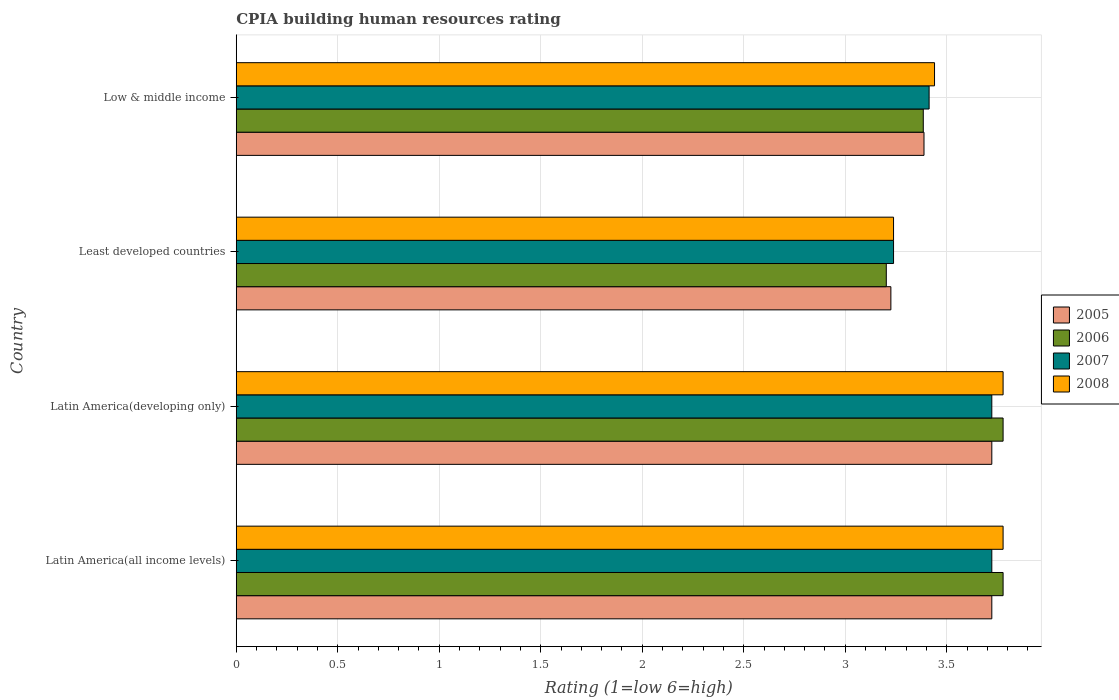Are the number of bars per tick equal to the number of legend labels?
Make the answer very short. Yes. What is the label of the 3rd group of bars from the top?
Keep it short and to the point. Latin America(developing only). In how many cases, is the number of bars for a given country not equal to the number of legend labels?
Ensure brevity in your answer.  0. What is the CPIA rating in 2005 in Latin America(developing only)?
Provide a succinct answer. 3.72. Across all countries, what is the maximum CPIA rating in 2006?
Give a very brief answer. 3.78. Across all countries, what is the minimum CPIA rating in 2005?
Give a very brief answer. 3.23. In which country was the CPIA rating in 2006 maximum?
Offer a very short reply. Latin America(all income levels). In which country was the CPIA rating in 2006 minimum?
Give a very brief answer. Least developed countries. What is the total CPIA rating in 2008 in the graph?
Provide a succinct answer. 14.23. What is the difference between the CPIA rating in 2005 in Latin America(all income levels) and the CPIA rating in 2006 in Low & middle income?
Provide a succinct answer. 0.34. What is the average CPIA rating in 2008 per country?
Provide a short and direct response. 3.56. What is the difference between the CPIA rating in 2005 and CPIA rating in 2008 in Latin America(all income levels)?
Your response must be concise. -0.06. In how many countries, is the CPIA rating in 2006 greater than 1.2 ?
Offer a terse response. 4. What is the ratio of the CPIA rating in 2007 in Latin America(all income levels) to that in Low & middle income?
Ensure brevity in your answer.  1.09. Is the difference between the CPIA rating in 2005 in Latin America(all income levels) and Low & middle income greater than the difference between the CPIA rating in 2008 in Latin America(all income levels) and Low & middle income?
Your answer should be compact. No. What is the difference between the highest and the lowest CPIA rating in 2006?
Your answer should be very brief. 0.58. In how many countries, is the CPIA rating in 2006 greater than the average CPIA rating in 2006 taken over all countries?
Ensure brevity in your answer.  2. Is it the case that in every country, the sum of the CPIA rating in 2005 and CPIA rating in 2007 is greater than the sum of CPIA rating in 2008 and CPIA rating in 2006?
Offer a terse response. No. What does the 1st bar from the top in Least developed countries represents?
Your answer should be very brief. 2008. How many bars are there?
Keep it short and to the point. 16. Are all the bars in the graph horizontal?
Provide a succinct answer. Yes. How are the legend labels stacked?
Ensure brevity in your answer.  Vertical. What is the title of the graph?
Offer a terse response. CPIA building human resources rating. What is the Rating (1=low 6=high) in 2005 in Latin America(all income levels)?
Ensure brevity in your answer.  3.72. What is the Rating (1=low 6=high) in 2006 in Latin America(all income levels)?
Your answer should be compact. 3.78. What is the Rating (1=low 6=high) of 2007 in Latin America(all income levels)?
Offer a terse response. 3.72. What is the Rating (1=low 6=high) in 2008 in Latin America(all income levels)?
Offer a terse response. 3.78. What is the Rating (1=low 6=high) of 2005 in Latin America(developing only)?
Your answer should be very brief. 3.72. What is the Rating (1=low 6=high) in 2006 in Latin America(developing only)?
Your response must be concise. 3.78. What is the Rating (1=low 6=high) of 2007 in Latin America(developing only)?
Your answer should be very brief. 3.72. What is the Rating (1=low 6=high) in 2008 in Latin America(developing only)?
Ensure brevity in your answer.  3.78. What is the Rating (1=low 6=high) of 2005 in Least developed countries?
Give a very brief answer. 3.23. What is the Rating (1=low 6=high) of 2006 in Least developed countries?
Provide a succinct answer. 3.2. What is the Rating (1=low 6=high) of 2007 in Least developed countries?
Keep it short and to the point. 3.24. What is the Rating (1=low 6=high) in 2008 in Least developed countries?
Ensure brevity in your answer.  3.24. What is the Rating (1=low 6=high) of 2005 in Low & middle income?
Offer a terse response. 3.39. What is the Rating (1=low 6=high) of 2006 in Low & middle income?
Keep it short and to the point. 3.38. What is the Rating (1=low 6=high) of 2007 in Low & middle income?
Your answer should be very brief. 3.41. What is the Rating (1=low 6=high) in 2008 in Low & middle income?
Make the answer very short. 3.44. Across all countries, what is the maximum Rating (1=low 6=high) of 2005?
Give a very brief answer. 3.72. Across all countries, what is the maximum Rating (1=low 6=high) of 2006?
Your response must be concise. 3.78. Across all countries, what is the maximum Rating (1=low 6=high) of 2007?
Give a very brief answer. 3.72. Across all countries, what is the maximum Rating (1=low 6=high) in 2008?
Your answer should be compact. 3.78. Across all countries, what is the minimum Rating (1=low 6=high) of 2005?
Keep it short and to the point. 3.23. Across all countries, what is the minimum Rating (1=low 6=high) of 2006?
Offer a terse response. 3.2. Across all countries, what is the minimum Rating (1=low 6=high) in 2007?
Ensure brevity in your answer.  3.24. Across all countries, what is the minimum Rating (1=low 6=high) of 2008?
Your response must be concise. 3.24. What is the total Rating (1=low 6=high) in 2005 in the graph?
Your response must be concise. 14.06. What is the total Rating (1=low 6=high) in 2006 in the graph?
Keep it short and to the point. 14.14. What is the total Rating (1=low 6=high) in 2007 in the graph?
Your answer should be very brief. 14.1. What is the total Rating (1=low 6=high) in 2008 in the graph?
Make the answer very short. 14.23. What is the difference between the Rating (1=low 6=high) of 2006 in Latin America(all income levels) and that in Latin America(developing only)?
Your response must be concise. 0. What is the difference between the Rating (1=low 6=high) in 2005 in Latin America(all income levels) and that in Least developed countries?
Your answer should be compact. 0.5. What is the difference between the Rating (1=low 6=high) of 2006 in Latin America(all income levels) and that in Least developed countries?
Give a very brief answer. 0.58. What is the difference between the Rating (1=low 6=high) of 2007 in Latin America(all income levels) and that in Least developed countries?
Keep it short and to the point. 0.48. What is the difference between the Rating (1=low 6=high) of 2008 in Latin America(all income levels) and that in Least developed countries?
Provide a succinct answer. 0.54. What is the difference between the Rating (1=low 6=high) of 2005 in Latin America(all income levels) and that in Low & middle income?
Provide a succinct answer. 0.33. What is the difference between the Rating (1=low 6=high) of 2006 in Latin America(all income levels) and that in Low & middle income?
Your answer should be very brief. 0.39. What is the difference between the Rating (1=low 6=high) in 2007 in Latin America(all income levels) and that in Low & middle income?
Give a very brief answer. 0.31. What is the difference between the Rating (1=low 6=high) of 2008 in Latin America(all income levels) and that in Low & middle income?
Your answer should be compact. 0.34. What is the difference between the Rating (1=low 6=high) in 2005 in Latin America(developing only) and that in Least developed countries?
Ensure brevity in your answer.  0.5. What is the difference between the Rating (1=low 6=high) in 2006 in Latin America(developing only) and that in Least developed countries?
Your answer should be compact. 0.58. What is the difference between the Rating (1=low 6=high) in 2007 in Latin America(developing only) and that in Least developed countries?
Make the answer very short. 0.48. What is the difference between the Rating (1=low 6=high) in 2008 in Latin America(developing only) and that in Least developed countries?
Offer a terse response. 0.54. What is the difference between the Rating (1=low 6=high) of 2005 in Latin America(developing only) and that in Low & middle income?
Keep it short and to the point. 0.33. What is the difference between the Rating (1=low 6=high) of 2006 in Latin America(developing only) and that in Low & middle income?
Your response must be concise. 0.39. What is the difference between the Rating (1=low 6=high) of 2007 in Latin America(developing only) and that in Low & middle income?
Ensure brevity in your answer.  0.31. What is the difference between the Rating (1=low 6=high) of 2008 in Latin America(developing only) and that in Low & middle income?
Your response must be concise. 0.34. What is the difference between the Rating (1=low 6=high) of 2005 in Least developed countries and that in Low & middle income?
Your answer should be compact. -0.16. What is the difference between the Rating (1=low 6=high) of 2006 in Least developed countries and that in Low & middle income?
Offer a terse response. -0.18. What is the difference between the Rating (1=low 6=high) in 2007 in Least developed countries and that in Low & middle income?
Provide a succinct answer. -0.18. What is the difference between the Rating (1=low 6=high) in 2008 in Least developed countries and that in Low & middle income?
Your response must be concise. -0.2. What is the difference between the Rating (1=low 6=high) in 2005 in Latin America(all income levels) and the Rating (1=low 6=high) in 2006 in Latin America(developing only)?
Keep it short and to the point. -0.06. What is the difference between the Rating (1=low 6=high) of 2005 in Latin America(all income levels) and the Rating (1=low 6=high) of 2007 in Latin America(developing only)?
Your answer should be compact. 0. What is the difference between the Rating (1=low 6=high) of 2005 in Latin America(all income levels) and the Rating (1=low 6=high) of 2008 in Latin America(developing only)?
Give a very brief answer. -0.06. What is the difference between the Rating (1=low 6=high) of 2006 in Latin America(all income levels) and the Rating (1=low 6=high) of 2007 in Latin America(developing only)?
Make the answer very short. 0.06. What is the difference between the Rating (1=low 6=high) of 2007 in Latin America(all income levels) and the Rating (1=low 6=high) of 2008 in Latin America(developing only)?
Offer a terse response. -0.06. What is the difference between the Rating (1=low 6=high) of 2005 in Latin America(all income levels) and the Rating (1=low 6=high) of 2006 in Least developed countries?
Offer a very short reply. 0.52. What is the difference between the Rating (1=low 6=high) in 2005 in Latin America(all income levels) and the Rating (1=low 6=high) in 2007 in Least developed countries?
Your response must be concise. 0.48. What is the difference between the Rating (1=low 6=high) of 2005 in Latin America(all income levels) and the Rating (1=low 6=high) of 2008 in Least developed countries?
Offer a very short reply. 0.48. What is the difference between the Rating (1=low 6=high) of 2006 in Latin America(all income levels) and the Rating (1=low 6=high) of 2007 in Least developed countries?
Your response must be concise. 0.54. What is the difference between the Rating (1=low 6=high) in 2006 in Latin America(all income levels) and the Rating (1=low 6=high) in 2008 in Least developed countries?
Provide a short and direct response. 0.54. What is the difference between the Rating (1=low 6=high) of 2007 in Latin America(all income levels) and the Rating (1=low 6=high) of 2008 in Least developed countries?
Keep it short and to the point. 0.48. What is the difference between the Rating (1=low 6=high) in 2005 in Latin America(all income levels) and the Rating (1=low 6=high) in 2006 in Low & middle income?
Your response must be concise. 0.34. What is the difference between the Rating (1=low 6=high) of 2005 in Latin America(all income levels) and the Rating (1=low 6=high) of 2007 in Low & middle income?
Offer a very short reply. 0.31. What is the difference between the Rating (1=low 6=high) in 2005 in Latin America(all income levels) and the Rating (1=low 6=high) in 2008 in Low & middle income?
Ensure brevity in your answer.  0.28. What is the difference between the Rating (1=low 6=high) in 2006 in Latin America(all income levels) and the Rating (1=low 6=high) in 2007 in Low & middle income?
Give a very brief answer. 0.36. What is the difference between the Rating (1=low 6=high) in 2006 in Latin America(all income levels) and the Rating (1=low 6=high) in 2008 in Low & middle income?
Your answer should be compact. 0.34. What is the difference between the Rating (1=low 6=high) of 2007 in Latin America(all income levels) and the Rating (1=low 6=high) of 2008 in Low & middle income?
Your response must be concise. 0.28. What is the difference between the Rating (1=low 6=high) in 2005 in Latin America(developing only) and the Rating (1=low 6=high) in 2006 in Least developed countries?
Offer a very short reply. 0.52. What is the difference between the Rating (1=low 6=high) of 2005 in Latin America(developing only) and the Rating (1=low 6=high) of 2007 in Least developed countries?
Give a very brief answer. 0.48. What is the difference between the Rating (1=low 6=high) in 2005 in Latin America(developing only) and the Rating (1=low 6=high) in 2008 in Least developed countries?
Ensure brevity in your answer.  0.48. What is the difference between the Rating (1=low 6=high) of 2006 in Latin America(developing only) and the Rating (1=low 6=high) of 2007 in Least developed countries?
Give a very brief answer. 0.54. What is the difference between the Rating (1=low 6=high) of 2006 in Latin America(developing only) and the Rating (1=low 6=high) of 2008 in Least developed countries?
Offer a very short reply. 0.54. What is the difference between the Rating (1=low 6=high) in 2007 in Latin America(developing only) and the Rating (1=low 6=high) in 2008 in Least developed countries?
Keep it short and to the point. 0.48. What is the difference between the Rating (1=low 6=high) of 2005 in Latin America(developing only) and the Rating (1=low 6=high) of 2006 in Low & middle income?
Ensure brevity in your answer.  0.34. What is the difference between the Rating (1=low 6=high) of 2005 in Latin America(developing only) and the Rating (1=low 6=high) of 2007 in Low & middle income?
Keep it short and to the point. 0.31. What is the difference between the Rating (1=low 6=high) of 2005 in Latin America(developing only) and the Rating (1=low 6=high) of 2008 in Low & middle income?
Your answer should be compact. 0.28. What is the difference between the Rating (1=low 6=high) of 2006 in Latin America(developing only) and the Rating (1=low 6=high) of 2007 in Low & middle income?
Your answer should be very brief. 0.36. What is the difference between the Rating (1=low 6=high) of 2006 in Latin America(developing only) and the Rating (1=low 6=high) of 2008 in Low & middle income?
Ensure brevity in your answer.  0.34. What is the difference between the Rating (1=low 6=high) in 2007 in Latin America(developing only) and the Rating (1=low 6=high) in 2008 in Low & middle income?
Your answer should be compact. 0.28. What is the difference between the Rating (1=low 6=high) of 2005 in Least developed countries and the Rating (1=low 6=high) of 2006 in Low & middle income?
Offer a terse response. -0.16. What is the difference between the Rating (1=low 6=high) in 2005 in Least developed countries and the Rating (1=low 6=high) in 2007 in Low & middle income?
Ensure brevity in your answer.  -0.19. What is the difference between the Rating (1=low 6=high) of 2005 in Least developed countries and the Rating (1=low 6=high) of 2008 in Low & middle income?
Make the answer very short. -0.21. What is the difference between the Rating (1=low 6=high) in 2006 in Least developed countries and the Rating (1=low 6=high) in 2007 in Low & middle income?
Your answer should be compact. -0.21. What is the difference between the Rating (1=low 6=high) in 2006 in Least developed countries and the Rating (1=low 6=high) in 2008 in Low & middle income?
Offer a terse response. -0.24. What is the difference between the Rating (1=low 6=high) of 2007 in Least developed countries and the Rating (1=low 6=high) of 2008 in Low & middle income?
Keep it short and to the point. -0.2. What is the average Rating (1=low 6=high) of 2005 per country?
Your response must be concise. 3.51. What is the average Rating (1=low 6=high) in 2006 per country?
Your answer should be compact. 3.54. What is the average Rating (1=low 6=high) in 2007 per country?
Make the answer very short. 3.52. What is the average Rating (1=low 6=high) in 2008 per country?
Your response must be concise. 3.56. What is the difference between the Rating (1=low 6=high) of 2005 and Rating (1=low 6=high) of 2006 in Latin America(all income levels)?
Give a very brief answer. -0.06. What is the difference between the Rating (1=low 6=high) in 2005 and Rating (1=low 6=high) in 2007 in Latin America(all income levels)?
Provide a short and direct response. 0. What is the difference between the Rating (1=low 6=high) in 2005 and Rating (1=low 6=high) in 2008 in Latin America(all income levels)?
Provide a succinct answer. -0.06. What is the difference between the Rating (1=low 6=high) of 2006 and Rating (1=low 6=high) of 2007 in Latin America(all income levels)?
Keep it short and to the point. 0.06. What is the difference between the Rating (1=low 6=high) of 2007 and Rating (1=low 6=high) of 2008 in Latin America(all income levels)?
Keep it short and to the point. -0.06. What is the difference between the Rating (1=low 6=high) in 2005 and Rating (1=low 6=high) in 2006 in Latin America(developing only)?
Provide a succinct answer. -0.06. What is the difference between the Rating (1=low 6=high) in 2005 and Rating (1=low 6=high) in 2007 in Latin America(developing only)?
Provide a succinct answer. 0. What is the difference between the Rating (1=low 6=high) in 2005 and Rating (1=low 6=high) in 2008 in Latin America(developing only)?
Provide a succinct answer. -0.06. What is the difference between the Rating (1=low 6=high) of 2006 and Rating (1=low 6=high) of 2007 in Latin America(developing only)?
Make the answer very short. 0.06. What is the difference between the Rating (1=low 6=high) in 2007 and Rating (1=low 6=high) in 2008 in Latin America(developing only)?
Your response must be concise. -0.06. What is the difference between the Rating (1=low 6=high) in 2005 and Rating (1=low 6=high) in 2006 in Least developed countries?
Keep it short and to the point. 0.02. What is the difference between the Rating (1=low 6=high) in 2005 and Rating (1=low 6=high) in 2007 in Least developed countries?
Provide a short and direct response. -0.01. What is the difference between the Rating (1=low 6=high) of 2005 and Rating (1=low 6=high) of 2008 in Least developed countries?
Your response must be concise. -0.01. What is the difference between the Rating (1=low 6=high) of 2006 and Rating (1=low 6=high) of 2007 in Least developed countries?
Provide a short and direct response. -0.04. What is the difference between the Rating (1=low 6=high) in 2006 and Rating (1=low 6=high) in 2008 in Least developed countries?
Give a very brief answer. -0.04. What is the difference between the Rating (1=low 6=high) of 2007 and Rating (1=low 6=high) of 2008 in Least developed countries?
Offer a terse response. 0. What is the difference between the Rating (1=low 6=high) of 2005 and Rating (1=low 6=high) of 2006 in Low & middle income?
Your answer should be very brief. 0. What is the difference between the Rating (1=low 6=high) in 2005 and Rating (1=low 6=high) in 2007 in Low & middle income?
Give a very brief answer. -0.03. What is the difference between the Rating (1=low 6=high) of 2005 and Rating (1=low 6=high) of 2008 in Low & middle income?
Make the answer very short. -0.05. What is the difference between the Rating (1=low 6=high) of 2006 and Rating (1=low 6=high) of 2007 in Low & middle income?
Give a very brief answer. -0.03. What is the difference between the Rating (1=low 6=high) of 2006 and Rating (1=low 6=high) of 2008 in Low & middle income?
Offer a terse response. -0.06. What is the difference between the Rating (1=low 6=high) in 2007 and Rating (1=low 6=high) in 2008 in Low & middle income?
Your answer should be compact. -0.03. What is the ratio of the Rating (1=low 6=high) of 2005 in Latin America(all income levels) to that in Latin America(developing only)?
Offer a very short reply. 1. What is the ratio of the Rating (1=low 6=high) in 2008 in Latin America(all income levels) to that in Latin America(developing only)?
Provide a short and direct response. 1. What is the ratio of the Rating (1=low 6=high) in 2005 in Latin America(all income levels) to that in Least developed countries?
Ensure brevity in your answer.  1.15. What is the ratio of the Rating (1=low 6=high) in 2006 in Latin America(all income levels) to that in Least developed countries?
Provide a succinct answer. 1.18. What is the ratio of the Rating (1=low 6=high) of 2007 in Latin America(all income levels) to that in Least developed countries?
Offer a terse response. 1.15. What is the ratio of the Rating (1=low 6=high) of 2005 in Latin America(all income levels) to that in Low & middle income?
Provide a short and direct response. 1.1. What is the ratio of the Rating (1=low 6=high) of 2006 in Latin America(all income levels) to that in Low & middle income?
Offer a terse response. 1.12. What is the ratio of the Rating (1=low 6=high) in 2007 in Latin America(all income levels) to that in Low & middle income?
Give a very brief answer. 1.09. What is the ratio of the Rating (1=low 6=high) in 2008 in Latin America(all income levels) to that in Low & middle income?
Give a very brief answer. 1.1. What is the ratio of the Rating (1=low 6=high) of 2005 in Latin America(developing only) to that in Least developed countries?
Make the answer very short. 1.15. What is the ratio of the Rating (1=low 6=high) of 2006 in Latin America(developing only) to that in Least developed countries?
Ensure brevity in your answer.  1.18. What is the ratio of the Rating (1=low 6=high) of 2007 in Latin America(developing only) to that in Least developed countries?
Give a very brief answer. 1.15. What is the ratio of the Rating (1=low 6=high) in 2005 in Latin America(developing only) to that in Low & middle income?
Offer a very short reply. 1.1. What is the ratio of the Rating (1=low 6=high) in 2006 in Latin America(developing only) to that in Low & middle income?
Offer a terse response. 1.12. What is the ratio of the Rating (1=low 6=high) in 2007 in Latin America(developing only) to that in Low & middle income?
Keep it short and to the point. 1.09. What is the ratio of the Rating (1=low 6=high) in 2008 in Latin America(developing only) to that in Low & middle income?
Provide a short and direct response. 1.1. What is the ratio of the Rating (1=low 6=high) in 2005 in Least developed countries to that in Low & middle income?
Offer a very short reply. 0.95. What is the ratio of the Rating (1=low 6=high) of 2006 in Least developed countries to that in Low & middle income?
Offer a terse response. 0.95. What is the ratio of the Rating (1=low 6=high) in 2007 in Least developed countries to that in Low & middle income?
Provide a short and direct response. 0.95. What is the ratio of the Rating (1=low 6=high) in 2008 in Least developed countries to that in Low & middle income?
Offer a terse response. 0.94. What is the difference between the highest and the second highest Rating (1=low 6=high) in 2006?
Your answer should be very brief. 0. What is the difference between the highest and the second highest Rating (1=low 6=high) of 2007?
Provide a succinct answer. 0. What is the difference between the highest and the lowest Rating (1=low 6=high) of 2005?
Make the answer very short. 0.5. What is the difference between the highest and the lowest Rating (1=low 6=high) of 2006?
Make the answer very short. 0.58. What is the difference between the highest and the lowest Rating (1=low 6=high) of 2007?
Your answer should be compact. 0.48. What is the difference between the highest and the lowest Rating (1=low 6=high) in 2008?
Ensure brevity in your answer.  0.54. 